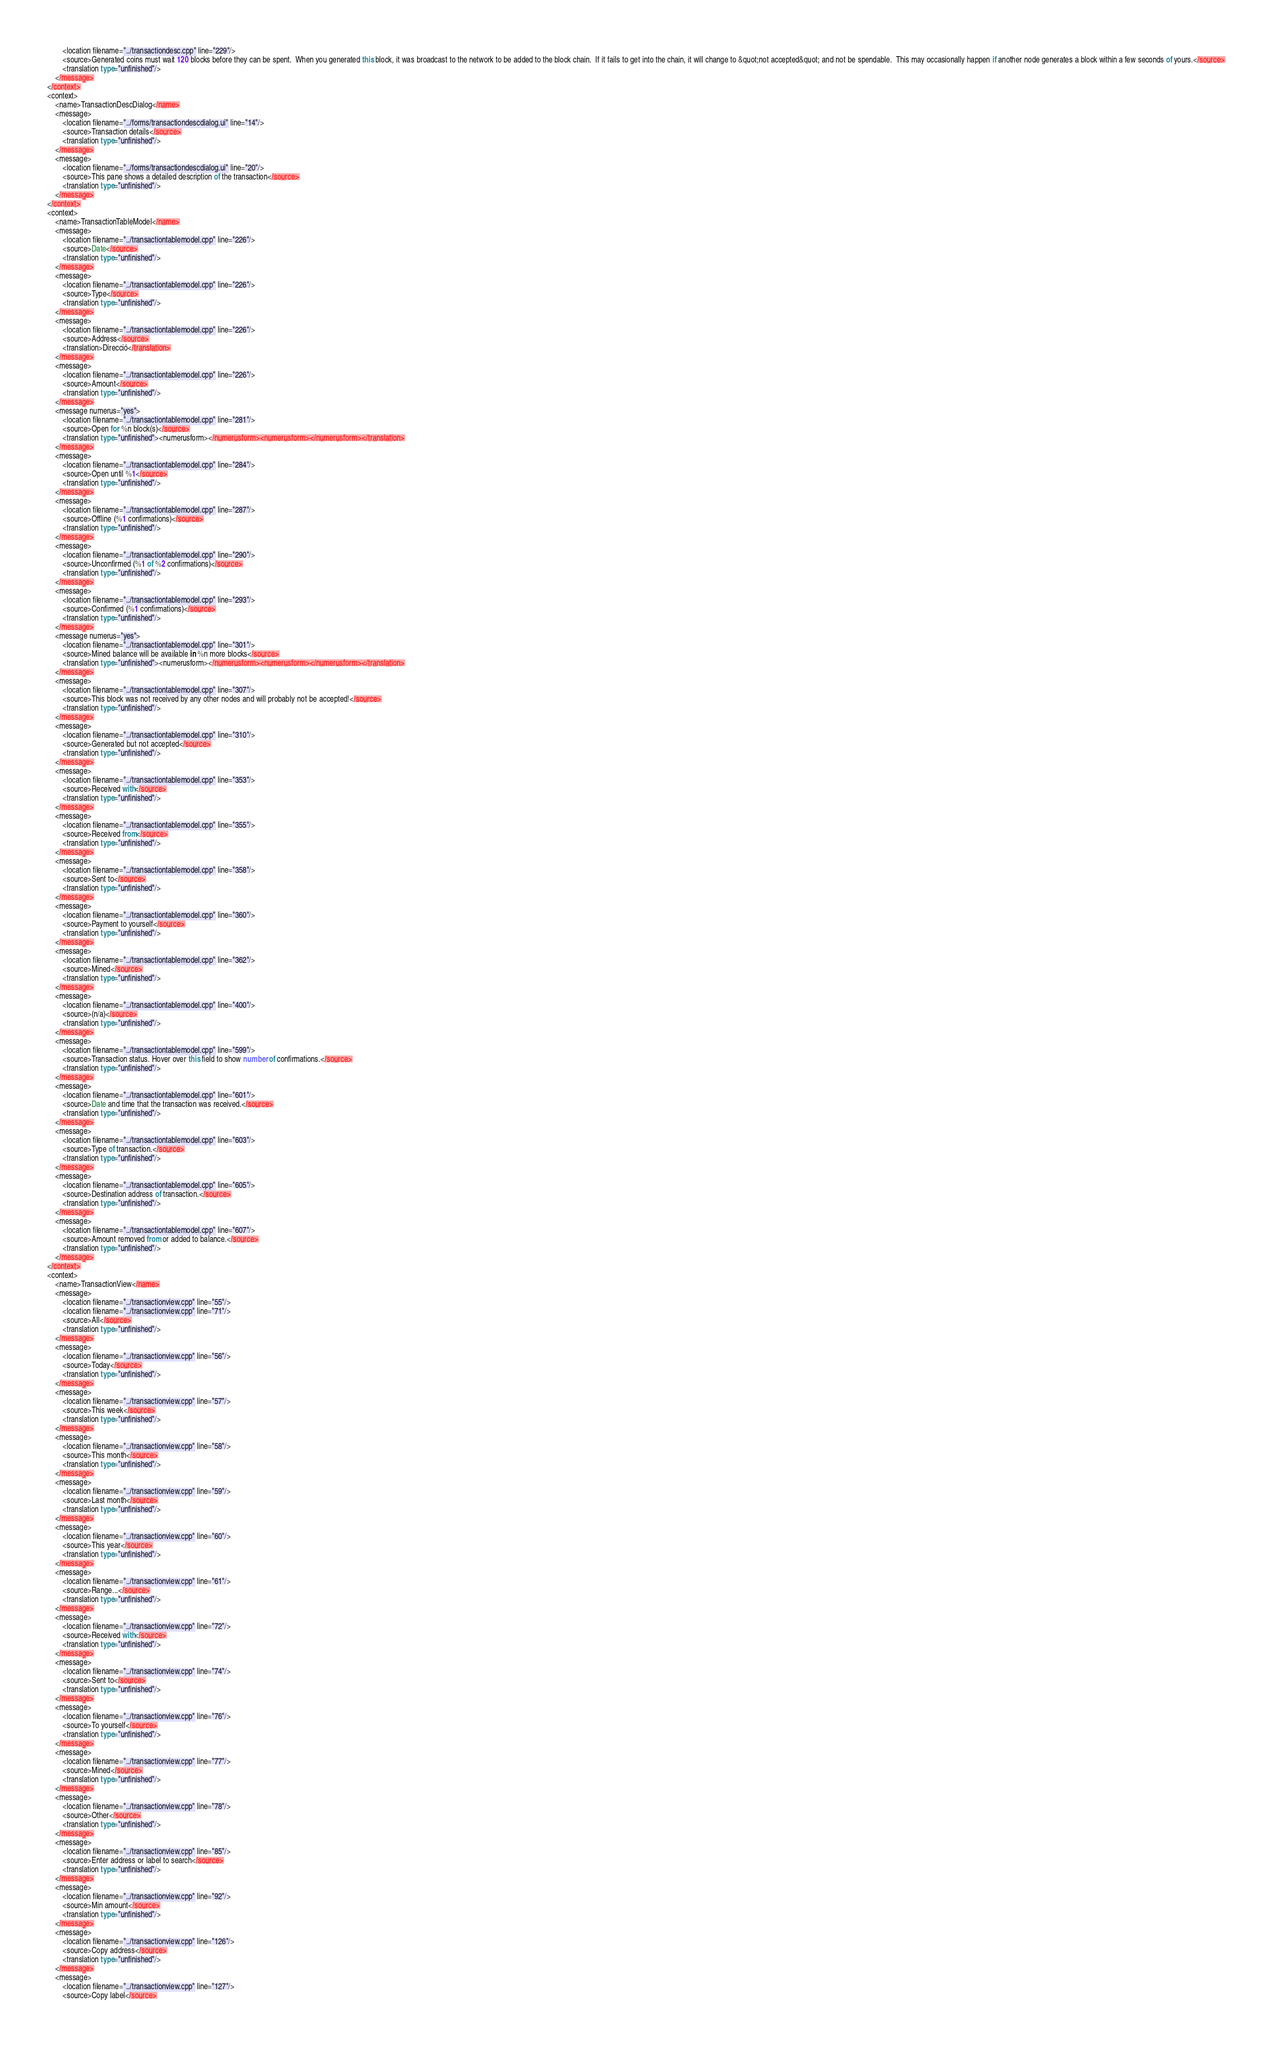Convert code to text. <code><loc_0><loc_0><loc_500><loc_500><_TypeScript_>        <location filename="../transactiondesc.cpp" line="229"/>
        <source>Generated coins must wait 120 blocks before they can be spent.  When you generated this block, it was broadcast to the network to be added to the block chain.  If it fails to get into the chain, it will change to &quot;not accepted&quot; and not be spendable.  This may occasionally happen if another node generates a block within a few seconds of yours.</source>
        <translation type="unfinished"/>
    </message>
</context>
<context>
    <name>TransactionDescDialog</name>
    <message>
        <location filename="../forms/transactiondescdialog.ui" line="14"/>
        <source>Transaction details</source>
        <translation type="unfinished"/>
    </message>
    <message>
        <location filename="../forms/transactiondescdialog.ui" line="20"/>
        <source>This pane shows a detailed description of the transaction</source>
        <translation type="unfinished"/>
    </message>
</context>
<context>
    <name>TransactionTableModel</name>
    <message>
        <location filename="../transactiontablemodel.cpp" line="226"/>
        <source>Date</source>
        <translation type="unfinished"/>
    </message>
    <message>
        <location filename="../transactiontablemodel.cpp" line="226"/>
        <source>Type</source>
        <translation type="unfinished"/>
    </message>
    <message>
        <location filename="../transactiontablemodel.cpp" line="226"/>
        <source>Address</source>
        <translation>Direcció</translation>
    </message>
    <message>
        <location filename="../transactiontablemodel.cpp" line="226"/>
        <source>Amount</source>
        <translation type="unfinished"/>
    </message>
    <message numerus="yes">
        <location filename="../transactiontablemodel.cpp" line="281"/>
        <source>Open for %n block(s)</source>
        <translation type="unfinished"><numerusform></numerusform><numerusform></numerusform></translation>
    </message>
    <message>
        <location filename="../transactiontablemodel.cpp" line="284"/>
        <source>Open until %1</source>
        <translation type="unfinished"/>
    </message>
    <message>
        <location filename="../transactiontablemodel.cpp" line="287"/>
        <source>Offline (%1 confirmations)</source>
        <translation type="unfinished"/>
    </message>
    <message>
        <location filename="../transactiontablemodel.cpp" line="290"/>
        <source>Unconfirmed (%1 of %2 confirmations)</source>
        <translation type="unfinished"/>
    </message>
    <message>
        <location filename="../transactiontablemodel.cpp" line="293"/>
        <source>Confirmed (%1 confirmations)</source>
        <translation type="unfinished"/>
    </message>
    <message numerus="yes">
        <location filename="../transactiontablemodel.cpp" line="301"/>
        <source>Mined balance will be available in %n more blocks</source>
        <translation type="unfinished"><numerusform></numerusform><numerusform></numerusform></translation>
    </message>
    <message>
        <location filename="../transactiontablemodel.cpp" line="307"/>
        <source>This block was not received by any other nodes and will probably not be accepted!</source>
        <translation type="unfinished"/>
    </message>
    <message>
        <location filename="../transactiontablemodel.cpp" line="310"/>
        <source>Generated but not accepted</source>
        <translation type="unfinished"/>
    </message>
    <message>
        <location filename="../transactiontablemodel.cpp" line="353"/>
        <source>Received with</source>
        <translation type="unfinished"/>
    </message>
    <message>
        <location filename="../transactiontablemodel.cpp" line="355"/>
        <source>Received from</source>
        <translation type="unfinished"/>
    </message>
    <message>
        <location filename="../transactiontablemodel.cpp" line="358"/>
        <source>Sent to</source>
        <translation type="unfinished"/>
    </message>
    <message>
        <location filename="../transactiontablemodel.cpp" line="360"/>
        <source>Payment to yourself</source>
        <translation type="unfinished"/>
    </message>
    <message>
        <location filename="../transactiontablemodel.cpp" line="362"/>
        <source>Mined</source>
        <translation type="unfinished"/>
    </message>
    <message>
        <location filename="../transactiontablemodel.cpp" line="400"/>
        <source>(n/a)</source>
        <translation type="unfinished"/>
    </message>
    <message>
        <location filename="../transactiontablemodel.cpp" line="599"/>
        <source>Transaction status. Hover over this field to show number of confirmations.</source>
        <translation type="unfinished"/>
    </message>
    <message>
        <location filename="../transactiontablemodel.cpp" line="601"/>
        <source>Date and time that the transaction was received.</source>
        <translation type="unfinished"/>
    </message>
    <message>
        <location filename="../transactiontablemodel.cpp" line="603"/>
        <source>Type of transaction.</source>
        <translation type="unfinished"/>
    </message>
    <message>
        <location filename="../transactiontablemodel.cpp" line="605"/>
        <source>Destination address of transaction.</source>
        <translation type="unfinished"/>
    </message>
    <message>
        <location filename="../transactiontablemodel.cpp" line="607"/>
        <source>Amount removed from or added to balance.</source>
        <translation type="unfinished"/>
    </message>
</context>
<context>
    <name>TransactionView</name>
    <message>
        <location filename="../transactionview.cpp" line="55"/>
        <location filename="../transactionview.cpp" line="71"/>
        <source>All</source>
        <translation type="unfinished"/>
    </message>
    <message>
        <location filename="../transactionview.cpp" line="56"/>
        <source>Today</source>
        <translation type="unfinished"/>
    </message>
    <message>
        <location filename="../transactionview.cpp" line="57"/>
        <source>This week</source>
        <translation type="unfinished"/>
    </message>
    <message>
        <location filename="../transactionview.cpp" line="58"/>
        <source>This month</source>
        <translation type="unfinished"/>
    </message>
    <message>
        <location filename="../transactionview.cpp" line="59"/>
        <source>Last month</source>
        <translation type="unfinished"/>
    </message>
    <message>
        <location filename="../transactionview.cpp" line="60"/>
        <source>This year</source>
        <translation type="unfinished"/>
    </message>
    <message>
        <location filename="../transactionview.cpp" line="61"/>
        <source>Range...</source>
        <translation type="unfinished"/>
    </message>
    <message>
        <location filename="../transactionview.cpp" line="72"/>
        <source>Received with</source>
        <translation type="unfinished"/>
    </message>
    <message>
        <location filename="../transactionview.cpp" line="74"/>
        <source>Sent to</source>
        <translation type="unfinished"/>
    </message>
    <message>
        <location filename="../transactionview.cpp" line="76"/>
        <source>To yourself</source>
        <translation type="unfinished"/>
    </message>
    <message>
        <location filename="../transactionview.cpp" line="77"/>
        <source>Mined</source>
        <translation type="unfinished"/>
    </message>
    <message>
        <location filename="../transactionview.cpp" line="78"/>
        <source>Other</source>
        <translation type="unfinished"/>
    </message>
    <message>
        <location filename="../transactionview.cpp" line="85"/>
        <source>Enter address or label to search</source>
        <translation type="unfinished"/>
    </message>
    <message>
        <location filename="../transactionview.cpp" line="92"/>
        <source>Min amount</source>
        <translation type="unfinished"/>
    </message>
    <message>
        <location filename="../transactionview.cpp" line="126"/>
        <source>Copy address</source>
        <translation type="unfinished"/>
    </message>
    <message>
        <location filename="../transactionview.cpp" line="127"/>
        <source>Copy label</source></code> 